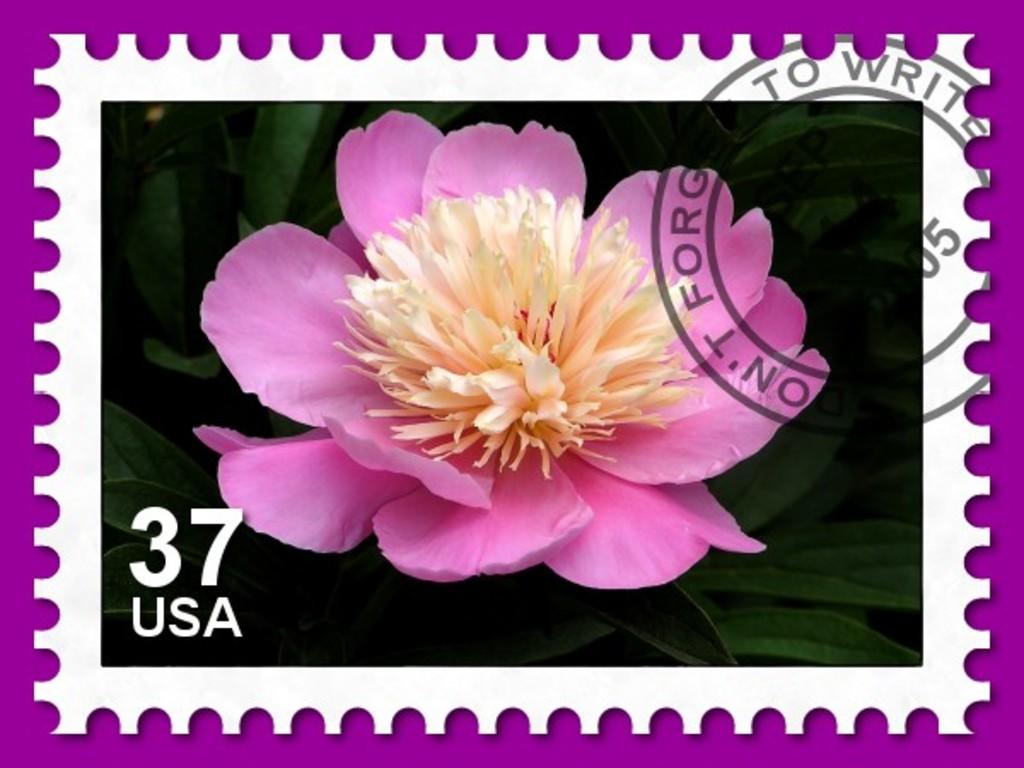What type of flower is visible in the image? There is a pink flower in the image. What can be seen behind the flower in the image? There are leaves behind the flower in the image. Is there any additional information or marking on the image? Yes, there is a watermark on the image. How does the butter melt in the image? There is no butter present in the image, so it cannot melt. 